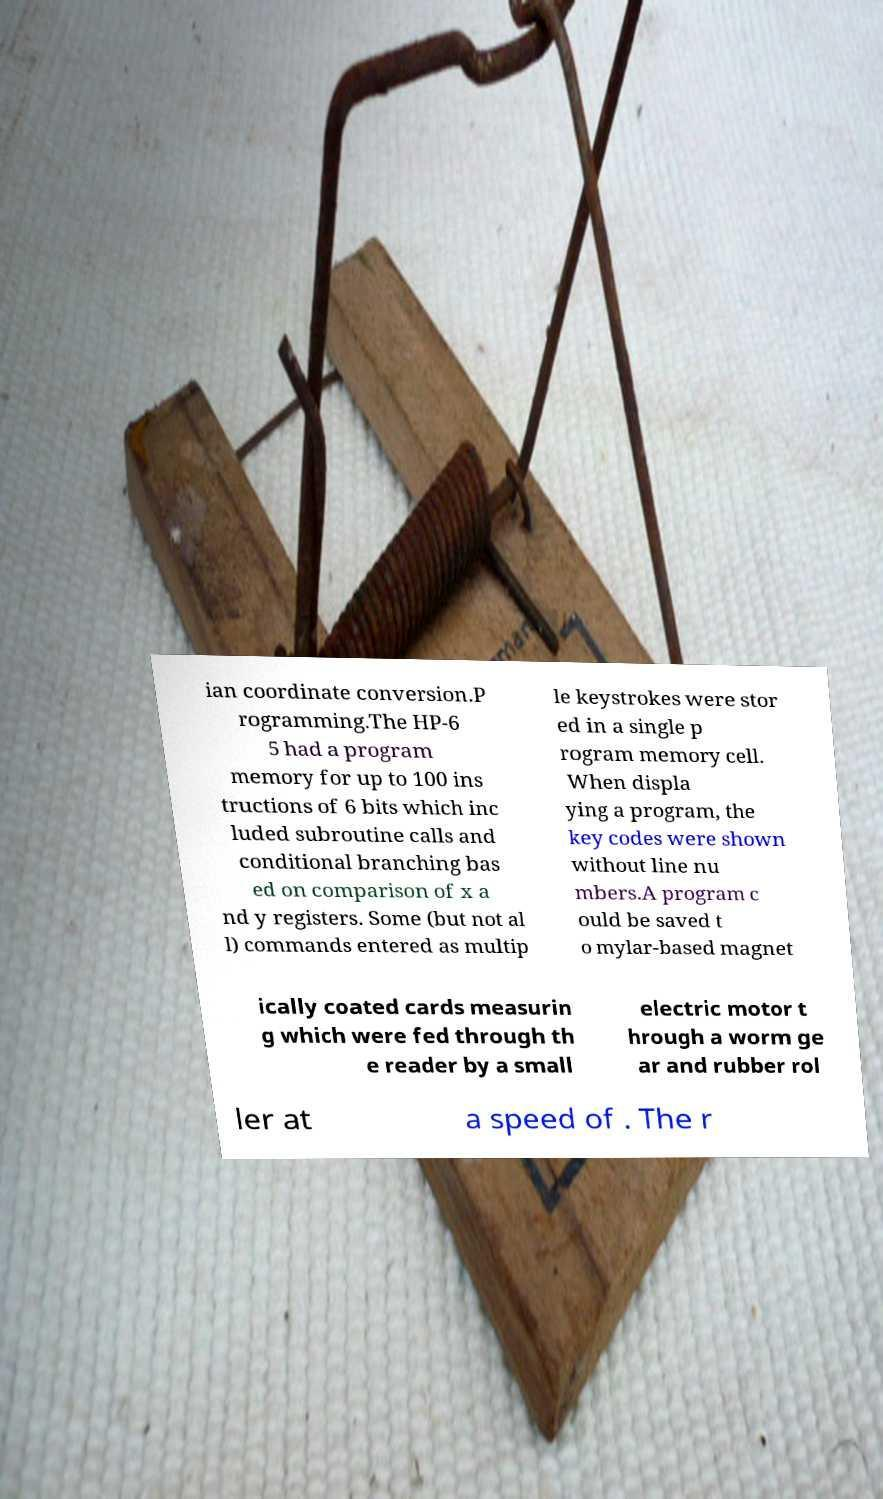Please identify and transcribe the text found in this image. ian coordinate conversion.P rogramming.The HP-6 5 had a program memory for up to 100 ins tructions of 6 bits which inc luded subroutine calls and conditional branching bas ed on comparison of x a nd y registers. Some (but not al l) commands entered as multip le keystrokes were stor ed in a single p rogram memory cell. When displa ying a program, the key codes were shown without line nu mbers.A program c ould be saved t o mylar-based magnet ically coated cards measurin g which were fed through th e reader by a small electric motor t hrough a worm ge ar and rubber rol ler at a speed of . The r 